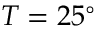<formula> <loc_0><loc_0><loc_500><loc_500>T = 2 5 ^ { \circ }</formula> 